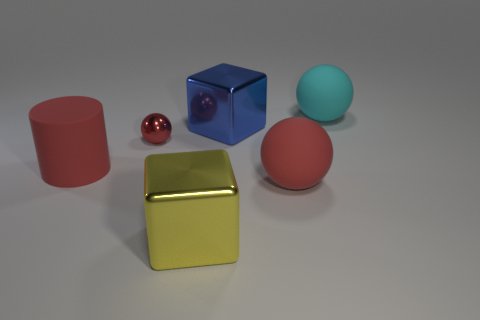What shape is the red object on the right side of the blue object?
Provide a short and direct response. Sphere. Is there anything else that has the same color as the tiny ball?
Provide a succinct answer. Yes. Are there fewer large balls behind the rubber cylinder than big metal things?
Your answer should be compact. Yes. How many other shiny spheres have the same size as the cyan ball?
Keep it short and to the point. 0. What shape is the metal object that is the same color as the rubber cylinder?
Offer a terse response. Sphere. There is a yellow object that is in front of the matte object that is to the left of the metal block that is behind the large yellow block; what is its shape?
Your answer should be compact. Cube. What color is the large sphere that is behind the tiny red sphere?
Offer a terse response. Cyan. How many things are red things that are to the left of the big yellow object or large shiny blocks in front of the small ball?
Ensure brevity in your answer.  3. What number of big blue things have the same shape as the tiny metallic thing?
Your answer should be very brief. 0. There is another shiny cube that is the same size as the blue shiny cube; what color is it?
Your answer should be compact. Yellow. 